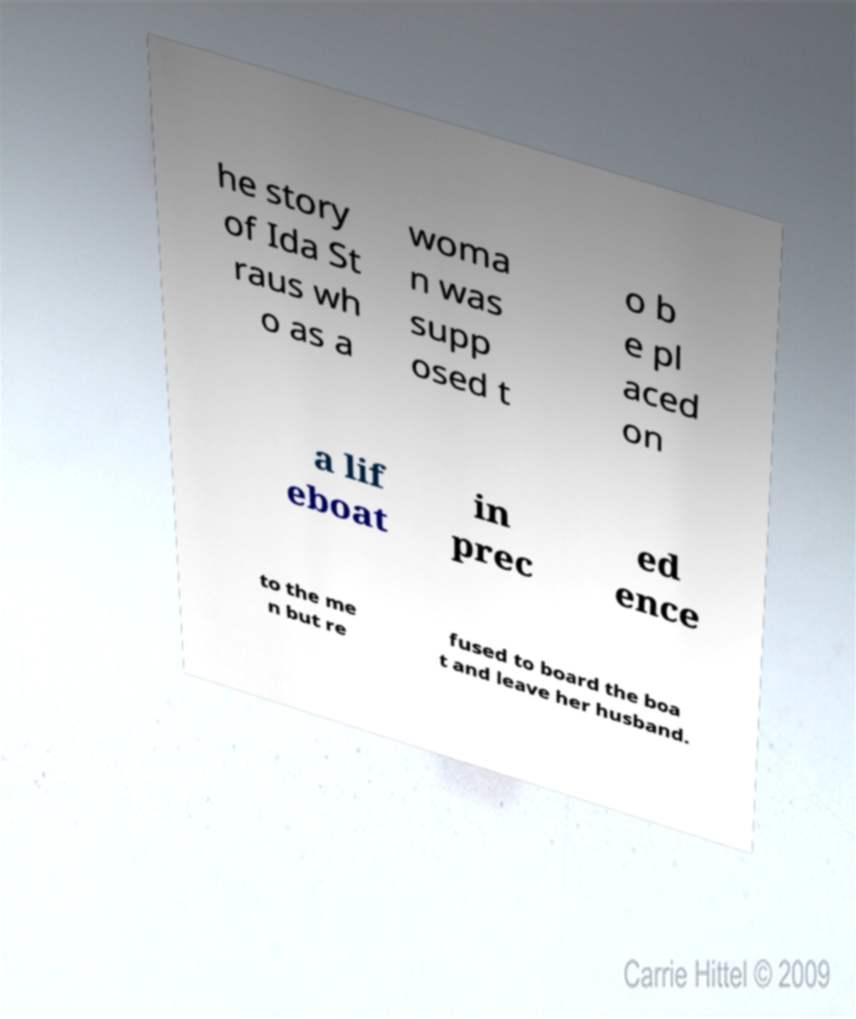Could you extract and type out the text from this image? he story of Ida St raus wh o as a woma n was supp osed t o b e pl aced on a lif eboat in prec ed ence to the me n but re fused to board the boa t and leave her husband. 